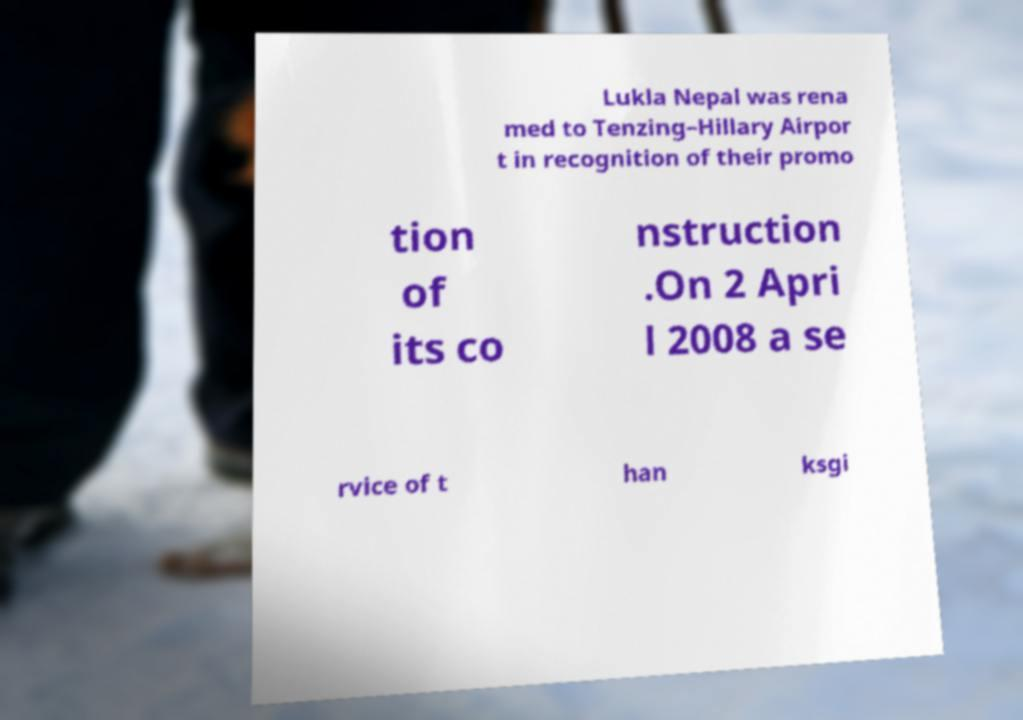Could you assist in decoding the text presented in this image and type it out clearly? Lukla Nepal was rena med to Tenzing–Hillary Airpor t in recognition of their promo tion of its co nstruction .On 2 Apri l 2008 a se rvice of t han ksgi 